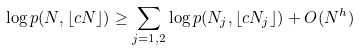Convert formula to latex. <formula><loc_0><loc_0><loc_500><loc_500>\log p ( N , \lfloor c N \rfloor ) \geq \sum _ { j = 1 , 2 } \log p ( N _ { j } , \lfloor c N _ { j } \rfloor ) + O ( N ^ { h } )</formula> 